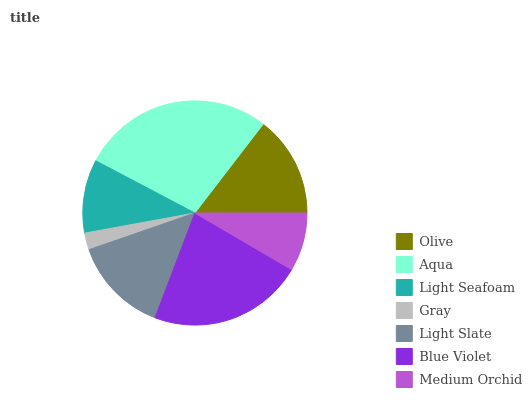Is Gray the minimum?
Answer yes or no. Yes. Is Aqua the maximum?
Answer yes or no. Yes. Is Light Seafoam the minimum?
Answer yes or no. No. Is Light Seafoam the maximum?
Answer yes or no. No. Is Aqua greater than Light Seafoam?
Answer yes or no. Yes. Is Light Seafoam less than Aqua?
Answer yes or no. Yes. Is Light Seafoam greater than Aqua?
Answer yes or no. No. Is Aqua less than Light Seafoam?
Answer yes or no. No. Is Light Slate the high median?
Answer yes or no. Yes. Is Light Slate the low median?
Answer yes or no. Yes. Is Medium Orchid the high median?
Answer yes or no. No. Is Aqua the low median?
Answer yes or no. No. 